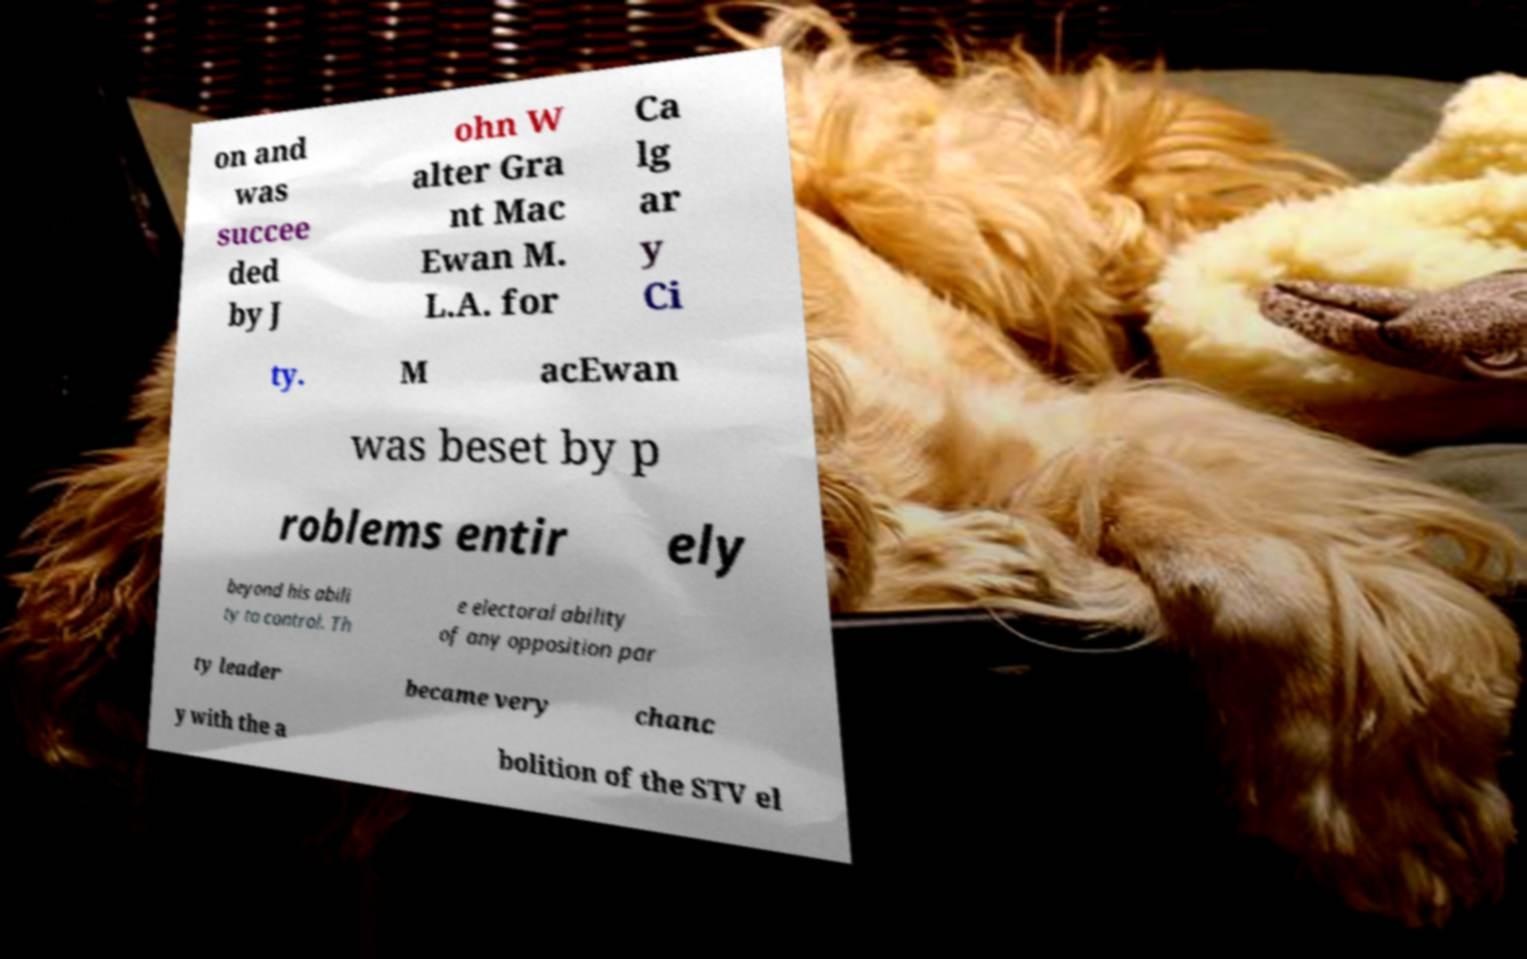Can you read and provide the text displayed in the image?This photo seems to have some interesting text. Can you extract and type it out for me? on and was succee ded by J ohn W alter Gra nt Mac Ewan M. L.A. for Ca lg ar y Ci ty. M acEwan was beset by p roblems entir ely beyond his abili ty to control. Th e electoral ability of any opposition par ty leader became very chanc y with the a bolition of the STV el 